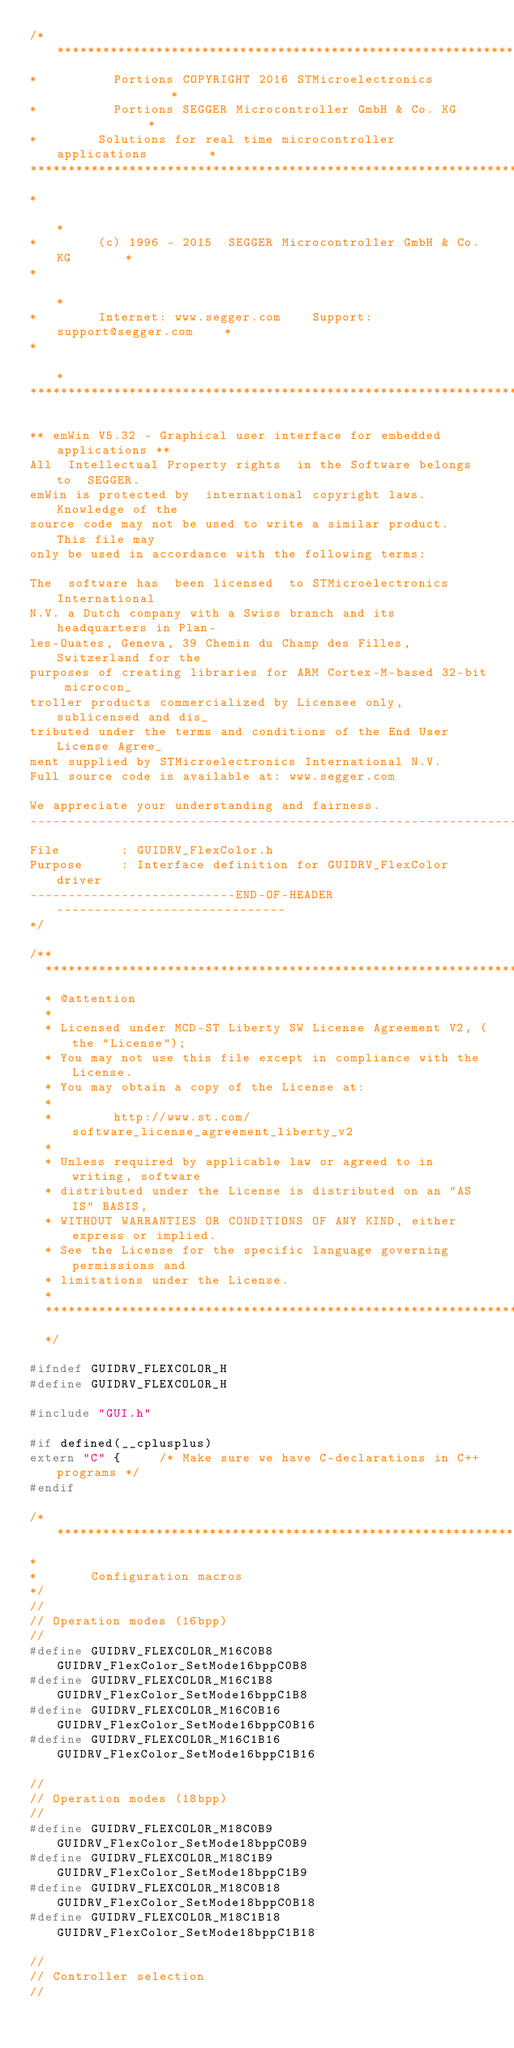Convert code to text. <code><loc_0><loc_0><loc_500><loc_500><_C_>/*********************************************************************
*          Portions COPYRIGHT 2016 STMicroelectronics                *
*          Portions SEGGER Microcontroller GmbH & Co. KG             *
*        Solutions for real time microcontroller applications        *
**********************************************************************
*                                                                    *
*        (c) 1996 - 2015  SEGGER Microcontroller GmbH & Co. KG       *
*                                                                    *
*        Internet: www.segger.com    Support:  support@segger.com    *
*                                                                    *
**********************************************************************

** emWin V5.32 - Graphical user interface for embedded applications **
All  Intellectual Property rights  in the Software belongs to  SEGGER.
emWin is protected by  international copyright laws.  Knowledge of the
source code may not be used to write a similar product.  This file may
only be used in accordance with the following terms:

The  software has  been licensed  to STMicroelectronics International
N.V. a Dutch company with a Swiss branch and its headquarters in Plan-
les-Ouates, Geneva, 39 Chemin du Champ des Filles, Switzerland for the
purposes of creating libraries for ARM Cortex-M-based 32-bit microcon_
troller products commercialized by Licensee only, sublicensed and dis_
tributed under the terms and conditions of the End User License Agree_
ment supplied by STMicroelectronics International N.V.
Full source code is available at: www.segger.com

We appreciate your understanding and fairness.
----------------------------------------------------------------------
File        : GUIDRV_FlexColor.h
Purpose     : Interface definition for GUIDRV_FlexColor driver
---------------------------END-OF-HEADER------------------------------
*/

/**
  ******************************************************************************
  * @attention
  *
  * Licensed under MCD-ST Liberty SW License Agreement V2, (the "License");
  * You may not use this file except in compliance with the License.
  * You may obtain a copy of the License at:
  *
  *        http://www.st.com/software_license_agreement_liberty_v2
  *
  * Unless required by applicable law or agreed to in writing, software 
  * distributed under the License is distributed on an "AS IS" BASIS, 
  * WITHOUT WARRANTIES OR CONDITIONS OF ANY KIND, either express or implied.
  * See the License for the specific language governing permissions and
  * limitations under the License.
  *
  ******************************************************************************
  */
  
#ifndef GUIDRV_FLEXCOLOR_H
#define GUIDRV_FLEXCOLOR_H

#include "GUI.h"

#if defined(__cplusplus)
extern "C" {     /* Make sure we have C-declarations in C++ programs */
#endif

/*********************************************************************
*
*       Configuration macros
*/
//
// Operation modes (16bpp)
//
#define GUIDRV_FLEXCOLOR_M16C0B8  GUIDRV_FlexColor_SetMode16bppC0B8
#define GUIDRV_FLEXCOLOR_M16C1B8  GUIDRV_FlexColor_SetMode16bppC1B8
#define GUIDRV_FLEXCOLOR_M16C0B16 GUIDRV_FlexColor_SetMode16bppC0B16
#define GUIDRV_FLEXCOLOR_M16C1B16 GUIDRV_FlexColor_SetMode16bppC1B16

//
// Operation modes (18bpp)
//
#define GUIDRV_FLEXCOLOR_M18C0B9  GUIDRV_FlexColor_SetMode18bppC0B9
#define GUIDRV_FLEXCOLOR_M18C1B9  GUIDRV_FlexColor_SetMode18bppC1B9
#define GUIDRV_FLEXCOLOR_M18C0B18 GUIDRV_FlexColor_SetMode18bppC0B18
#define GUIDRV_FLEXCOLOR_M18C1B18 GUIDRV_FlexColor_SetMode18bppC1B18

//
// Controller selection
//</code> 